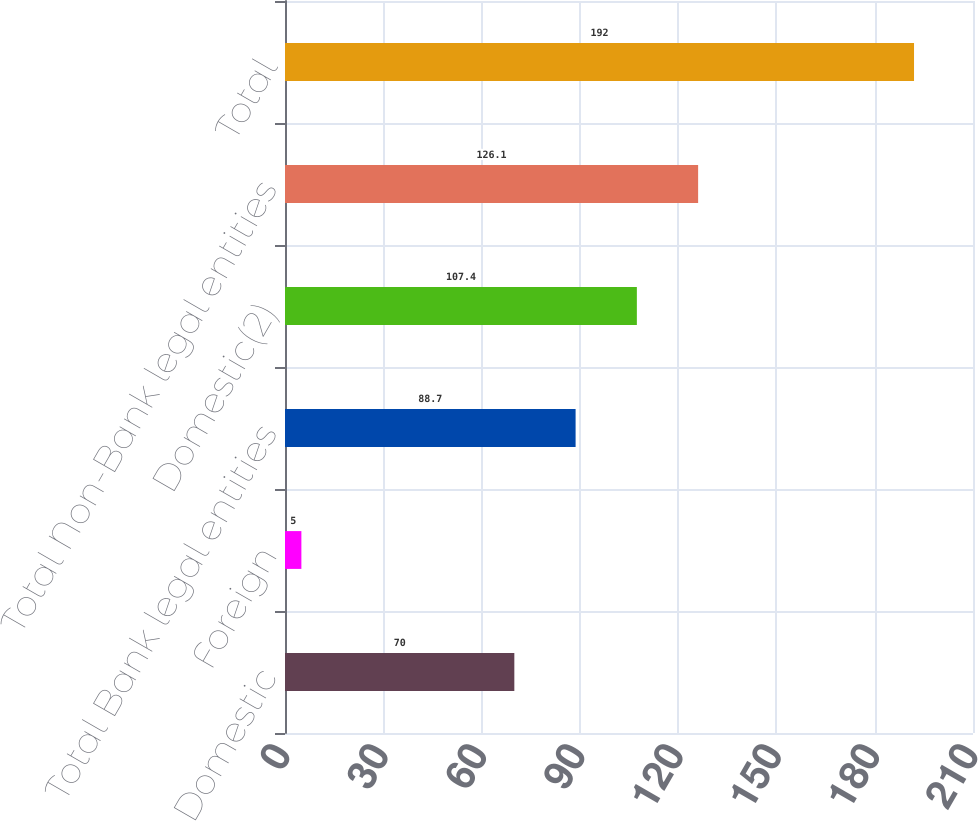Convert chart. <chart><loc_0><loc_0><loc_500><loc_500><bar_chart><fcel>Domestic<fcel>Foreign<fcel>Total Bank legal entities<fcel>Domestic(2)<fcel>Total Non-Bank legal entities<fcel>Total<nl><fcel>70<fcel>5<fcel>88.7<fcel>107.4<fcel>126.1<fcel>192<nl></chart> 